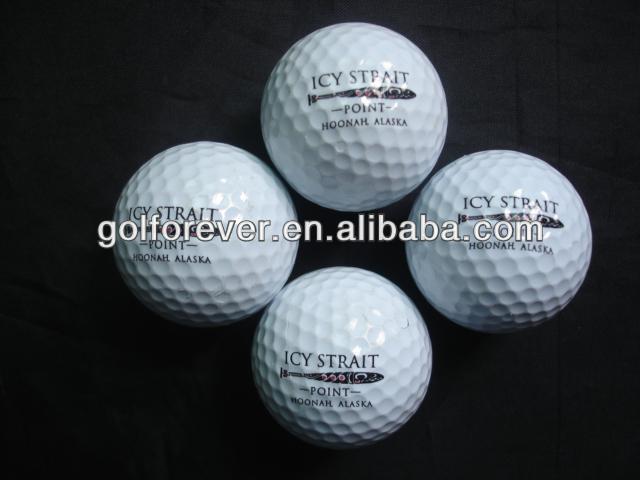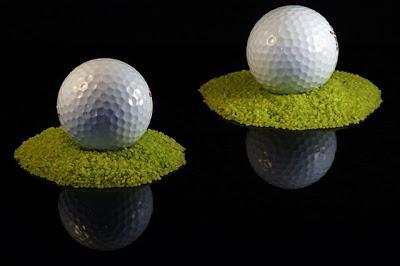The first image is the image on the left, the second image is the image on the right. Considering the images on both sides, is "The right image includes at least one golf tee, and the left image shows a pair of balls side-by-side." valid? Answer yes or no. No. The first image is the image on the left, the second image is the image on the right. Considering the images on both sides, is "The right image contains exactly two golf balls." valid? Answer yes or no. Yes. 